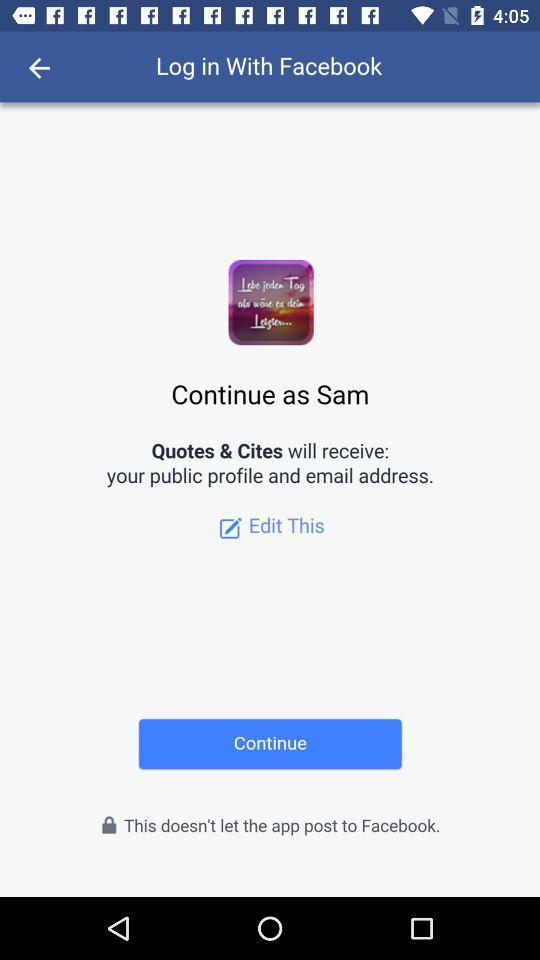How can we log in? You can log in with "Facebook". 